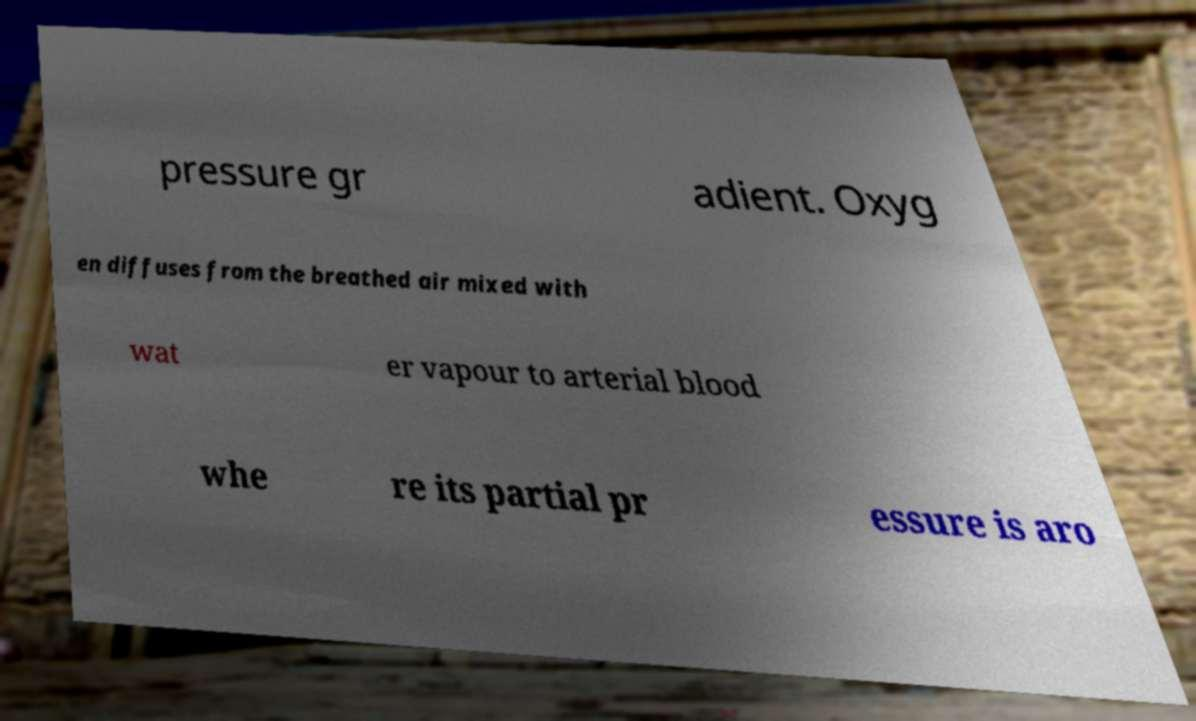What messages or text are displayed in this image? I need them in a readable, typed format. pressure gr adient. Oxyg en diffuses from the breathed air mixed with wat er vapour to arterial blood whe re its partial pr essure is aro 